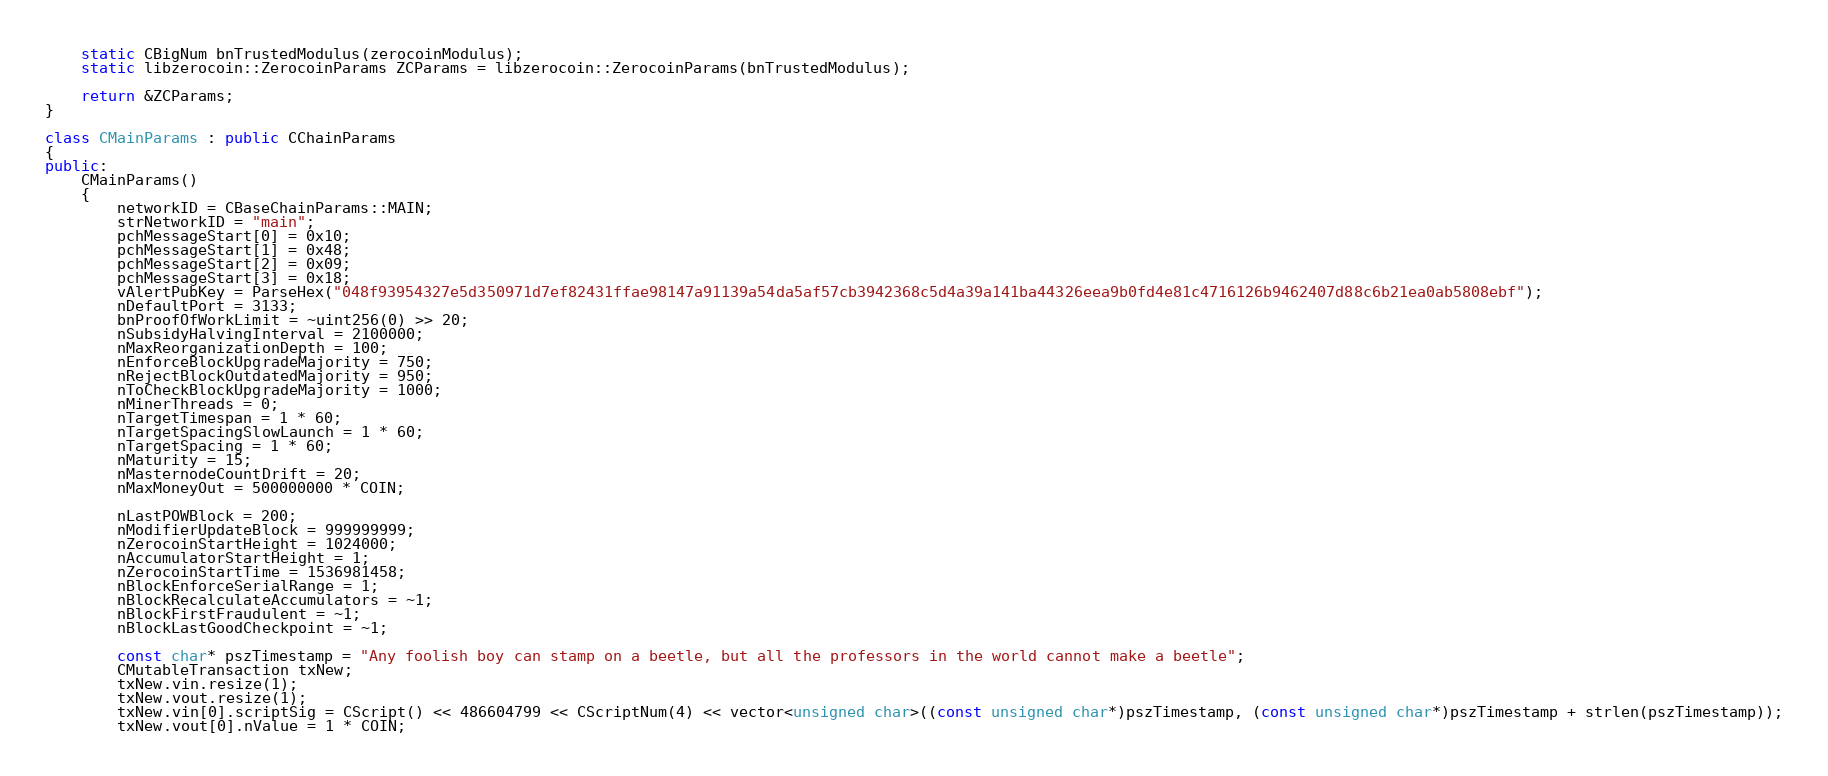Convert code to text. <code><loc_0><loc_0><loc_500><loc_500><_C++_>    static CBigNum bnTrustedModulus(zerocoinModulus);
    static libzerocoin::ZerocoinParams ZCParams = libzerocoin::ZerocoinParams(bnTrustedModulus);

    return &ZCParams;
}

class CMainParams : public CChainParams
{
public:
    CMainParams()
    {
        networkID = CBaseChainParams::MAIN;
        strNetworkID = "main";
        pchMessageStart[0] = 0x10;
        pchMessageStart[1] = 0x48;
        pchMessageStart[2] = 0x09;
        pchMessageStart[3] = 0x18;
        vAlertPubKey = ParseHex("048f93954327e5d350971d7ef82431ffae98147a91139a54da5af57cb3942368c5d4a39a141ba44326eea9b0fd4e81c4716126b9462407d88c6b21ea0ab5808ebf");
        nDefaultPort = 3133;
        bnProofOfWorkLimit = ~uint256(0) >> 20;
        nSubsidyHalvingInterval = 2100000;
        nMaxReorganizationDepth = 100;
        nEnforceBlockUpgradeMajority = 750;
        nRejectBlockOutdatedMajority = 950;
        nToCheckBlockUpgradeMajority = 1000;
        nMinerThreads = 0;
        nTargetTimespan = 1 * 60;
        nTargetSpacingSlowLaunch = 1 * 60;
        nTargetSpacing = 1 * 60;
        nMaturity = 15;
        nMasternodeCountDrift = 20;
        nMaxMoneyOut = 500000000 * COIN;

        nLastPOWBlock = 200;
        nModifierUpdateBlock = 999999999;
        nZerocoinStartHeight = 1024000;
        nAccumulatorStartHeight = 1;
        nZerocoinStartTime = 1536981458;
        nBlockEnforceSerialRange = 1;
        nBlockRecalculateAccumulators = ~1;
        nBlockFirstFraudulent = ~1;
        nBlockLastGoodCheckpoint = ~1;

        const char* pszTimestamp = "Any foolish boy can stamp on a beetle, but all the professors in the world cannot make a beetle";
        CMutableTransaction txNew;
        txNew.vin.resize(1);
        txNew.vout.resize(1);
        txNew.vin[0].scriptSig = CScript() << 486604799 << CScriptNum(4) << vector<unsigned char>((const unsigned char*)pszTimestamp, (const unsigned char*)pszTimestamp + strlen(pszTimestamp));
        txNew.vout[0].nValue = 1 * COIN;</code> 